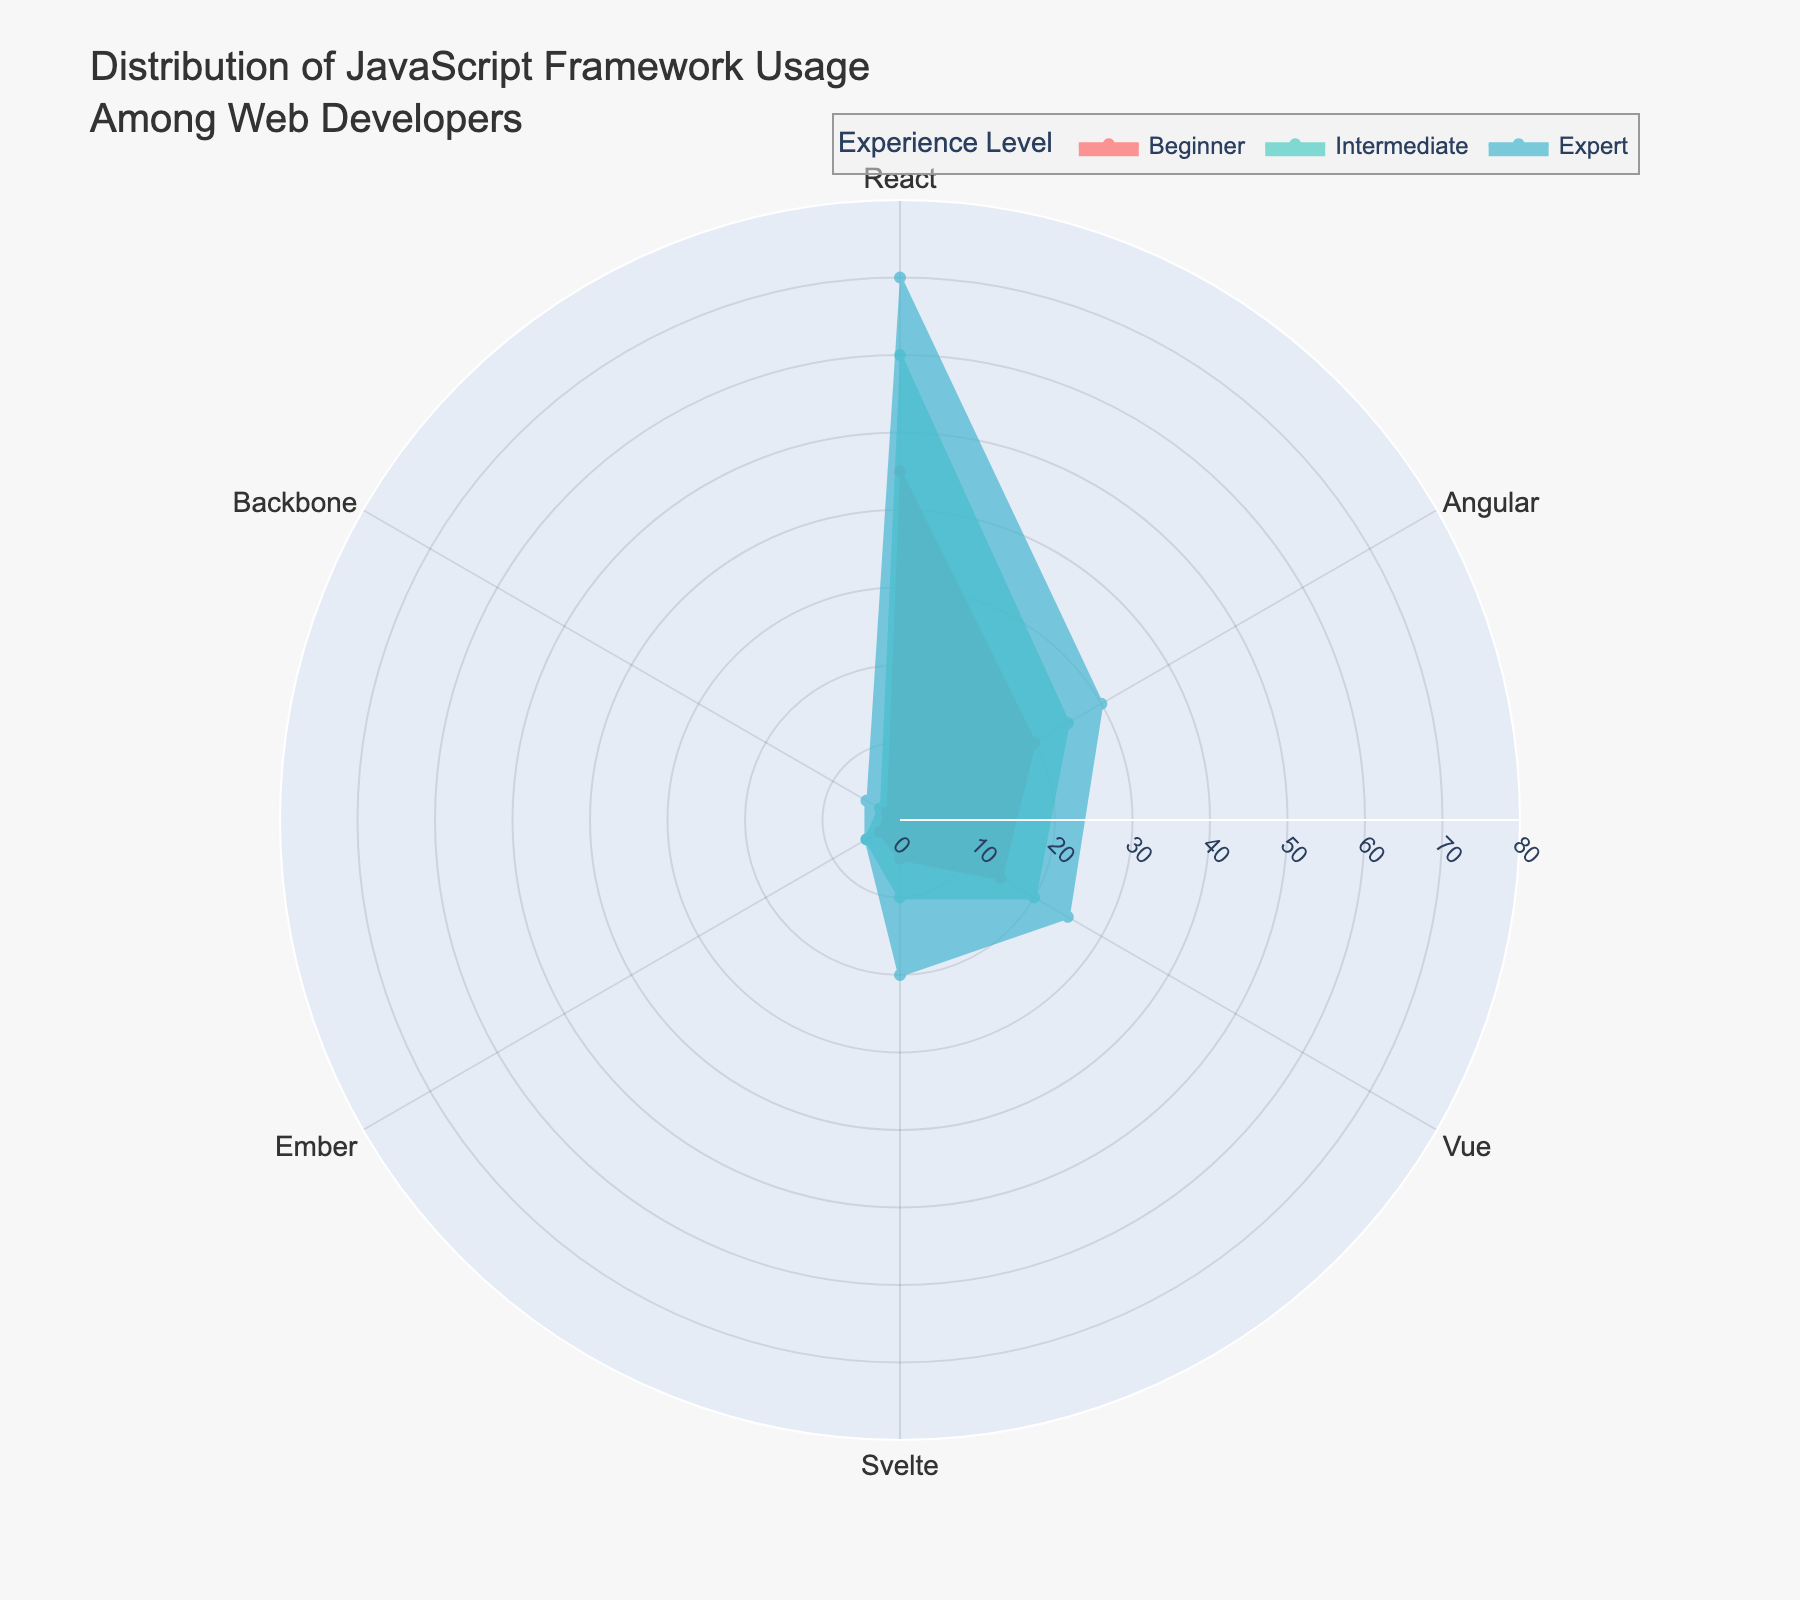What framework has the highest usage percentage among beginners? To find the framework with the highest usage percentage among beginners, look at the "Beginner" category and find the framework with the largest radial distance. React has the highest value at 45%.
Answer: React Which experience level has the highest percentage usage for Svelte? Examine the Svelte portion of the polar area chart and compare the percentages across beginner, intermediate, and expert levels. The expert level has the highest value at 20%.
Answer: Expert How does the usage of Angular compare between beginners and experts? To compare Angular usage, find the radial distances for both beginners and experts. Beginners have a usage percentage of 20%, whereas experts have 30%. Experts use Angular more.
Answer: Experts use Angular more Which framework shows the smallest usage percentage consistently across all experience levels? Look for the framework with the smallest radial distances across beginner, intermediate, and expert levels. Ember has the smallest values at 3%, 5%, and 5%.
Answer: Ember What's the combined usage percentage of Vue at the beginner and intermediate levels? Add the usage percentages for Vue at the beginner (15%) and intermediate (20%) levels. 15 + 20 = 35.
Answer: 35% Does any framework have an equal usage percentage between any two experience levels? Check the radial distances for each framework at different experience levels. Ember has equal usage percentages of 5% at both intermediate and expert levels.
Answer: Yes, Ember at intermediate and expert levels What is the average usage percentage of React across all experience levels? Sum the usage percentages for React across beginner (45%), intermediate (60%), and expert (70%) levels, then divide by 3. (45 + 60 + 70) / 3 = 58.33%.
Answer: 58.33% Is the usage of Backbone greater among experts than beginners? Compare the radial distances for Backbone between beginners (2%) and experts (5%). The expert level has a higher percentage.
Answer: Yes What is the range of usage percentages for Vue across all experience levels? Find the minimum and maximum percentages for Vue at beginner (15%), intermediate (20%), and expert (25%) levels. The range is 25 - 15 = 10.
Answer: 10% Which experience level shows the highest usage percentage overall for any framework? Identify the highest value in the chart. React at the expert level has the highest overall percentage of 70%.
Answer: Expert for React 